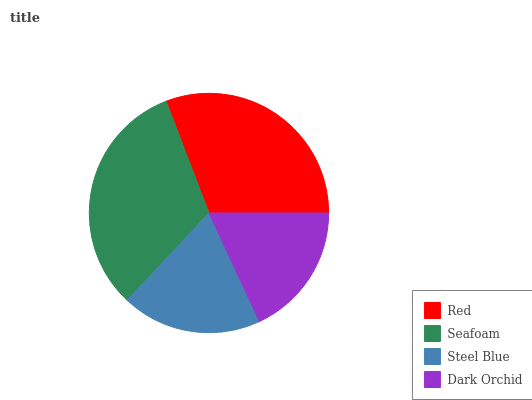Is Dark Orchid the minimum?
Answer yes or no. Yes. Is Seafoam the maximum?
Answer yes or no. Yes. Is Steel Blue the minimum?
Answer yes or no. No. Is Steel Blue the maximum?
Answer yes or no. No. Is Seafoam greater than Steel Blue?
Answer yes or no. Yes. Is Steel Blue less than Seafoam?
Answer yes or no. Yes. Is Steel Blue greater than Seafoam?
Answer yes or no. No. Is Seafoam less than Steel Blue?
Answer yes or no. No. Is Red the high median?
Answer yes or no. Yes. Is Steel Blue the low median?
Answer yes or no. Yes. Is Seafoam the high median?
Answer yes or no. No. Is Seafoam the low median?
Answer yes or no. No. 